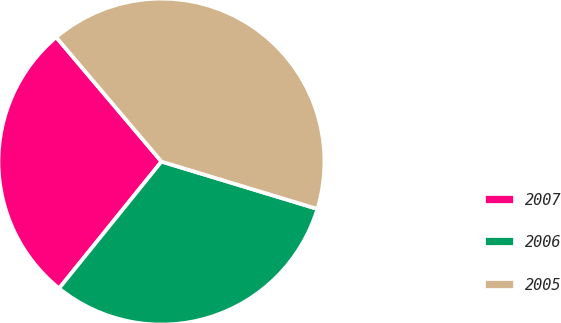Convert chart. <chart><loc_0><loc_0><loc_500><loc_500><pie_chart><fcel>2007<fcel>2006<fcel>2005<nl><fcel>28.01%<fcel>31.12%<fcel>40.87%<nl></chart> 